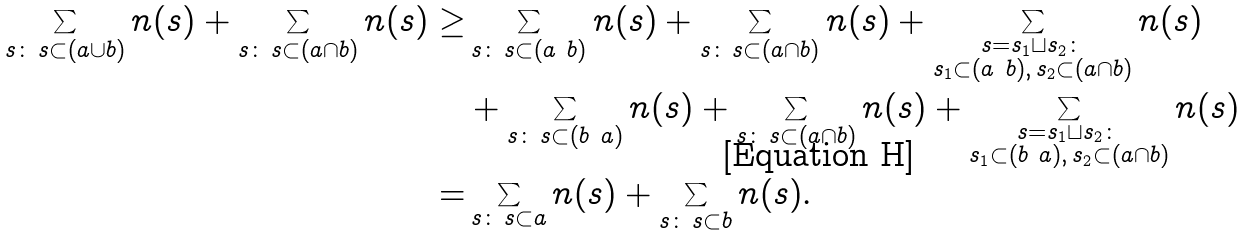Convert formula to latex. <formula><loc_0><loc_0><loc_500><loc_500>\sum _ { s \colon \, s \subset ( a \cup b ) } n ( s ) + \sum _ { s \colon \, s \subset ( a \cap b ) } n ( s ) \geq & \sum _ { s \colon \, s \subset ( a \ b ) } n ( s ) + \sum _ { s \colon \, s \subset ( a \cap b ) } n ( s ) + \sum _ { \substack { s = s _ { 1 } \sqcup s _ { 2 } \colon \\ s _ { 1 } \subset ( a \ b ) , \, s _ { 2 } \subset ( a \cap b ) } } n ( s ) \\ & + \sum _ { s \colon \, s \subset ( b \ a ) } n ( s ) + \sum _ { s \colon \, s \subset ( a \cap b ) } n ( s ) + \sum _ { \substack { s = s _ { 1 } \sqcup s _ { 2 } \colon \\ s _ { 1 } \subset ( b \ a ) , \, s _ { 2 } \subset ( a \cap b ) } } n ( s ) \\ = & \sum _ { s \colon \, s \subset a } n ( s ) + \sum _ { s \colon \, s \subset b } n ( s ) .</formula> 